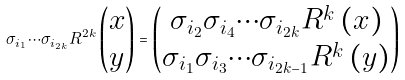<formula> <loc_0><loc_0><loc_500><loc_500>\sigma _ { i _ { 1 } } \cdots \sigma _ { i _ { 2 k } } R ^ { 2 k } \begin{pmatrix} x \\ y \end{pmatrix} = \begin{pmatrix} \sigma _ { i _ { 2 } } \sigma _ { i _ { 4 } } \cdots \sigma _ { i _ { 2 k } } R ^ { k } \left ( x \right ) \\ \sigma _ { i _ { 1 } } \sigma _ { i _ { 3 } } \cdots \sigma _ { i _ { 2 k - 1 } } R ^ { k } \left ( y \right ) \end{pmatrix}</formula> 